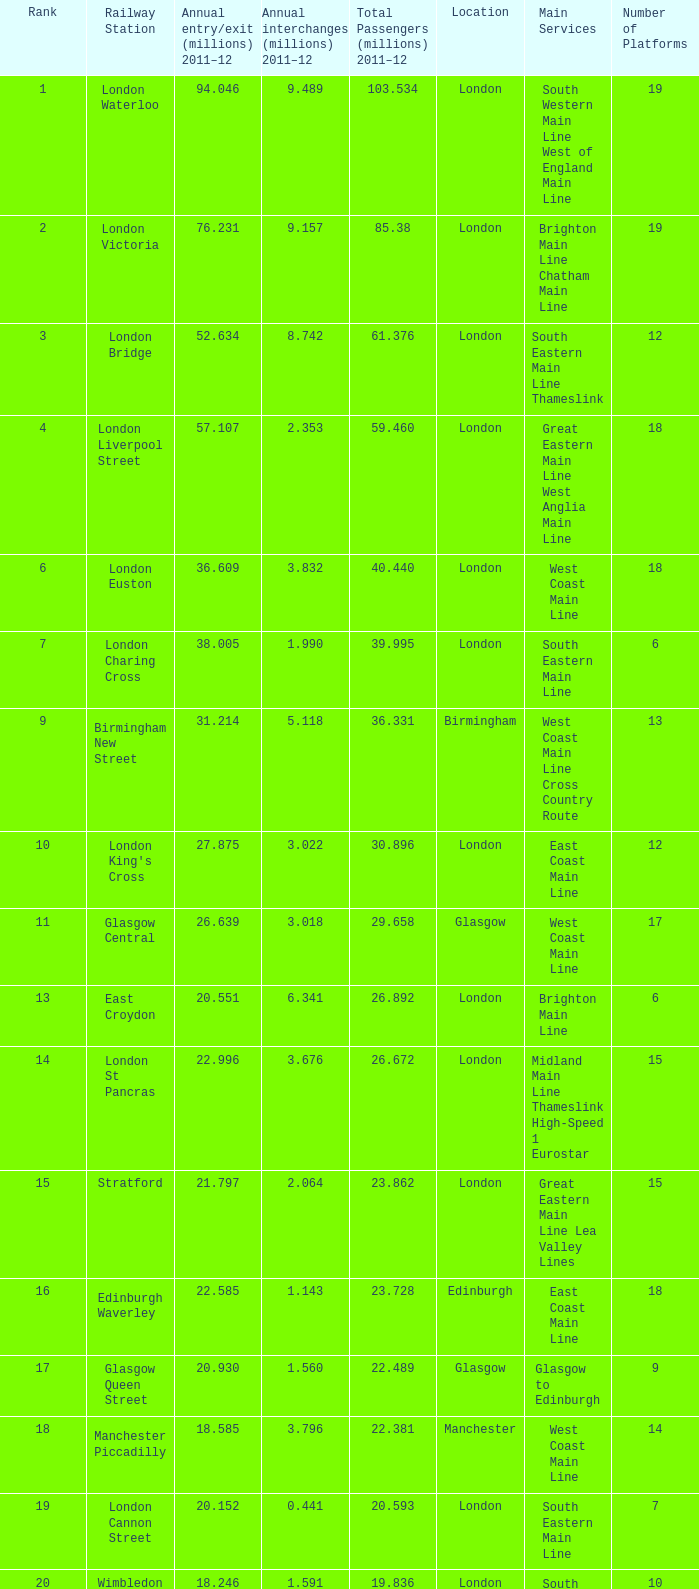How many annual interchanges in the millions occurred in 2011-12 when the number of annual entry/exits was 36.609 million?  3.832. 